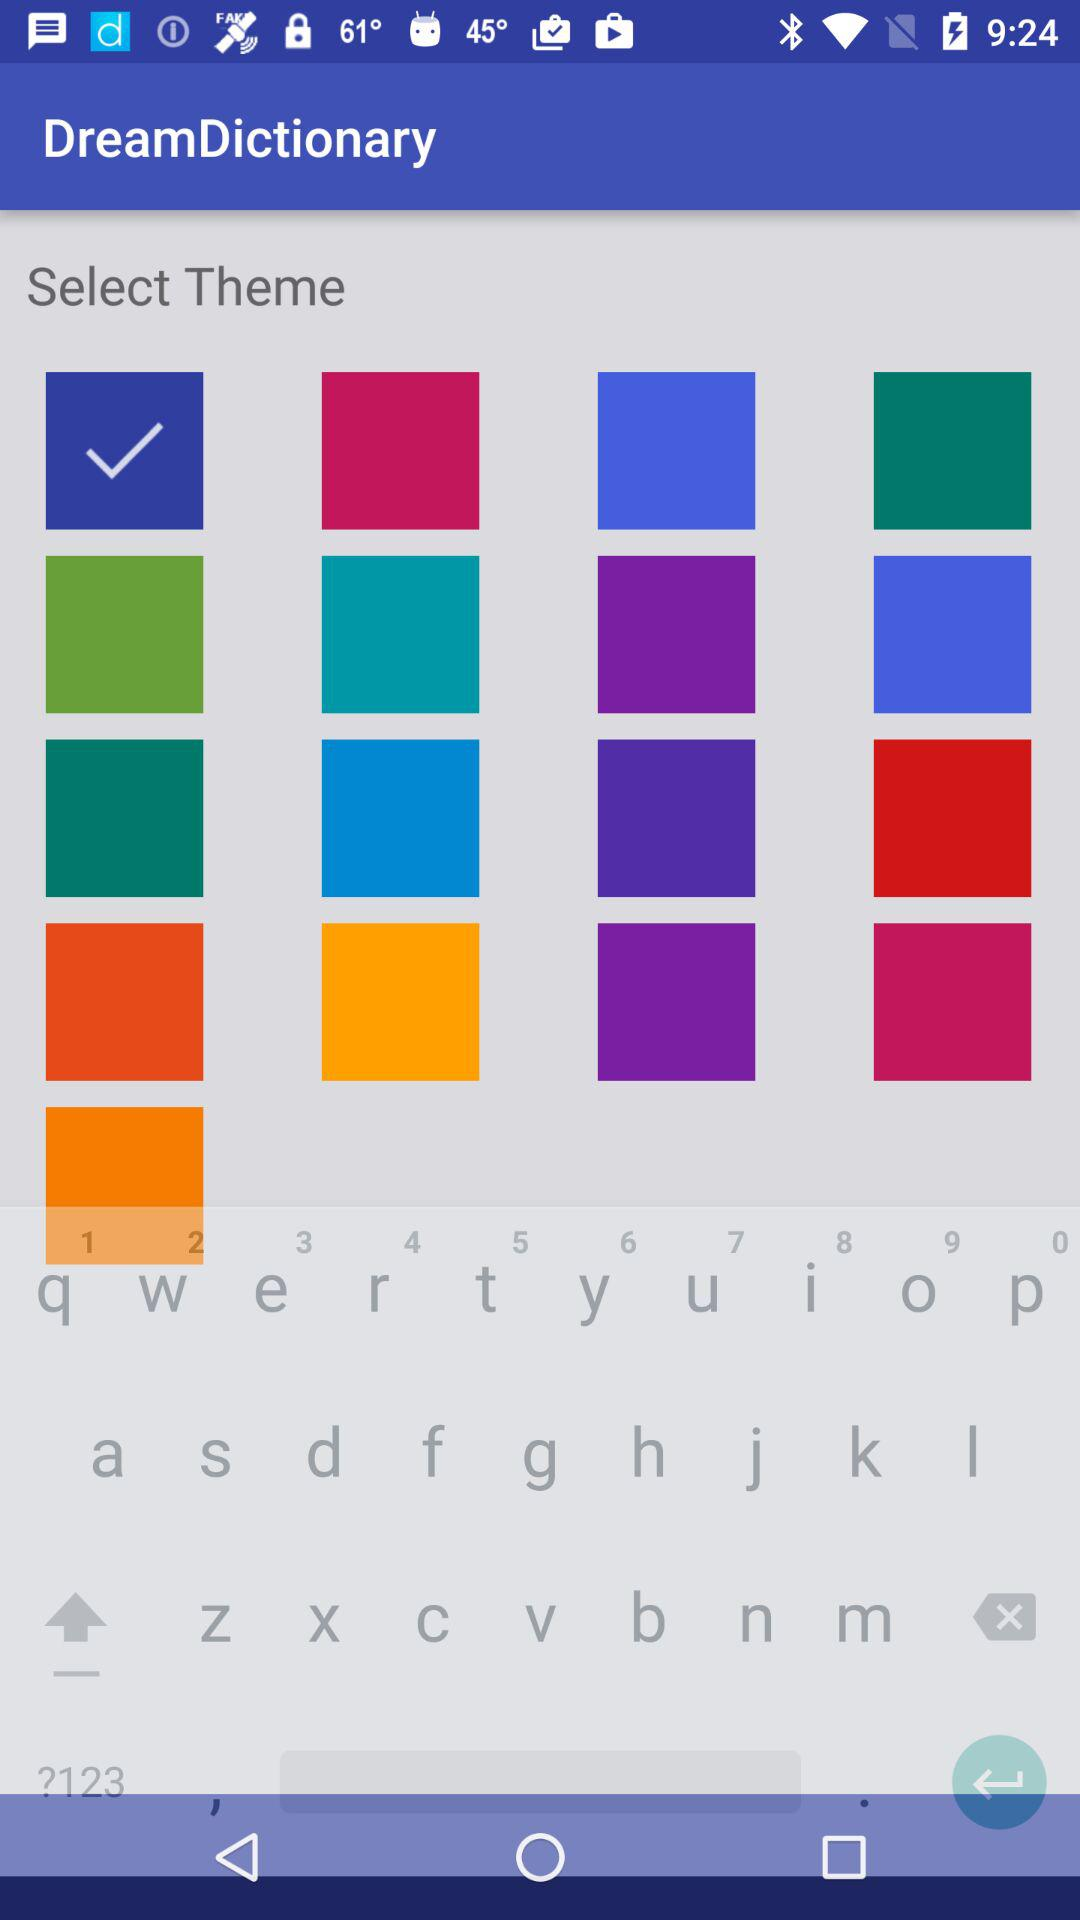What is the name of the application? The name of the application is "DreamDictionary". 